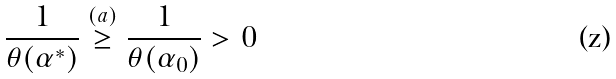<formula> <loc_0><loc_0><loc_500><loc_500>\frac { 1 } { \theta ( \alpha ^ { * } ) } \overset { ( a ) } { \geq } \frac { 1 } { \theta ( \alpha _ { 0 } ) } > 0</formula> 